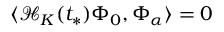Convert formula to latex. <formula><loc_0><loc_0><loc_500><loc_500>\langle \mathcal { H } _ { K } ( t _ { * } ) \Phi _ { 0 } , \Phi _ { \alpha } \rangle = 0</formula> 